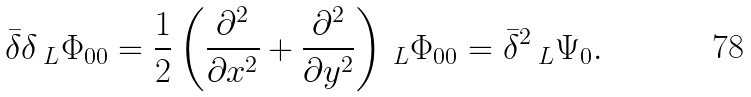<formula> <loc_0><loc_0><loc_500><loc_500>\bar { \delta } \delta \, _ { L } \Phi _ { 0 0 } = \frac { 1 } { 2 } \left ( \frac { \partial ^ { 2 } } { \partial x ^ { 2 } } + \frac { \partial ^ { 2 } } { \partial y ^ { 2 } } \right ) \, _ { L } \Phi _ { 0 0 } = \bar { \delta } ^ { 2 } \, _ { L } \Psi _ { 0 } .</formula> 